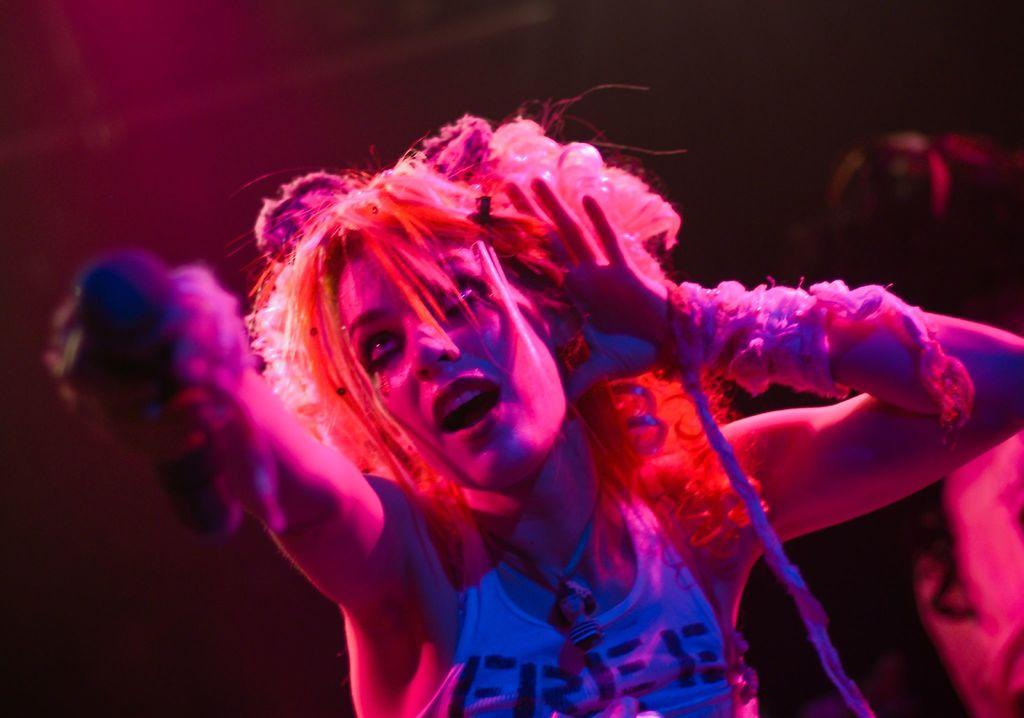Who is the main subject in the image? There is a lady in the center of the image. What is the lady holding in her hand? The lady is holding a mic in her hand. Can you describe the person in the background of the image? There is another person in the background of the image. What is the caption written below the image? There is no caption present in the image. Can you tell me the name of the actor in the image? There is no actor mentioned in the image, and we do not have enough information to identify any individuals by name. 